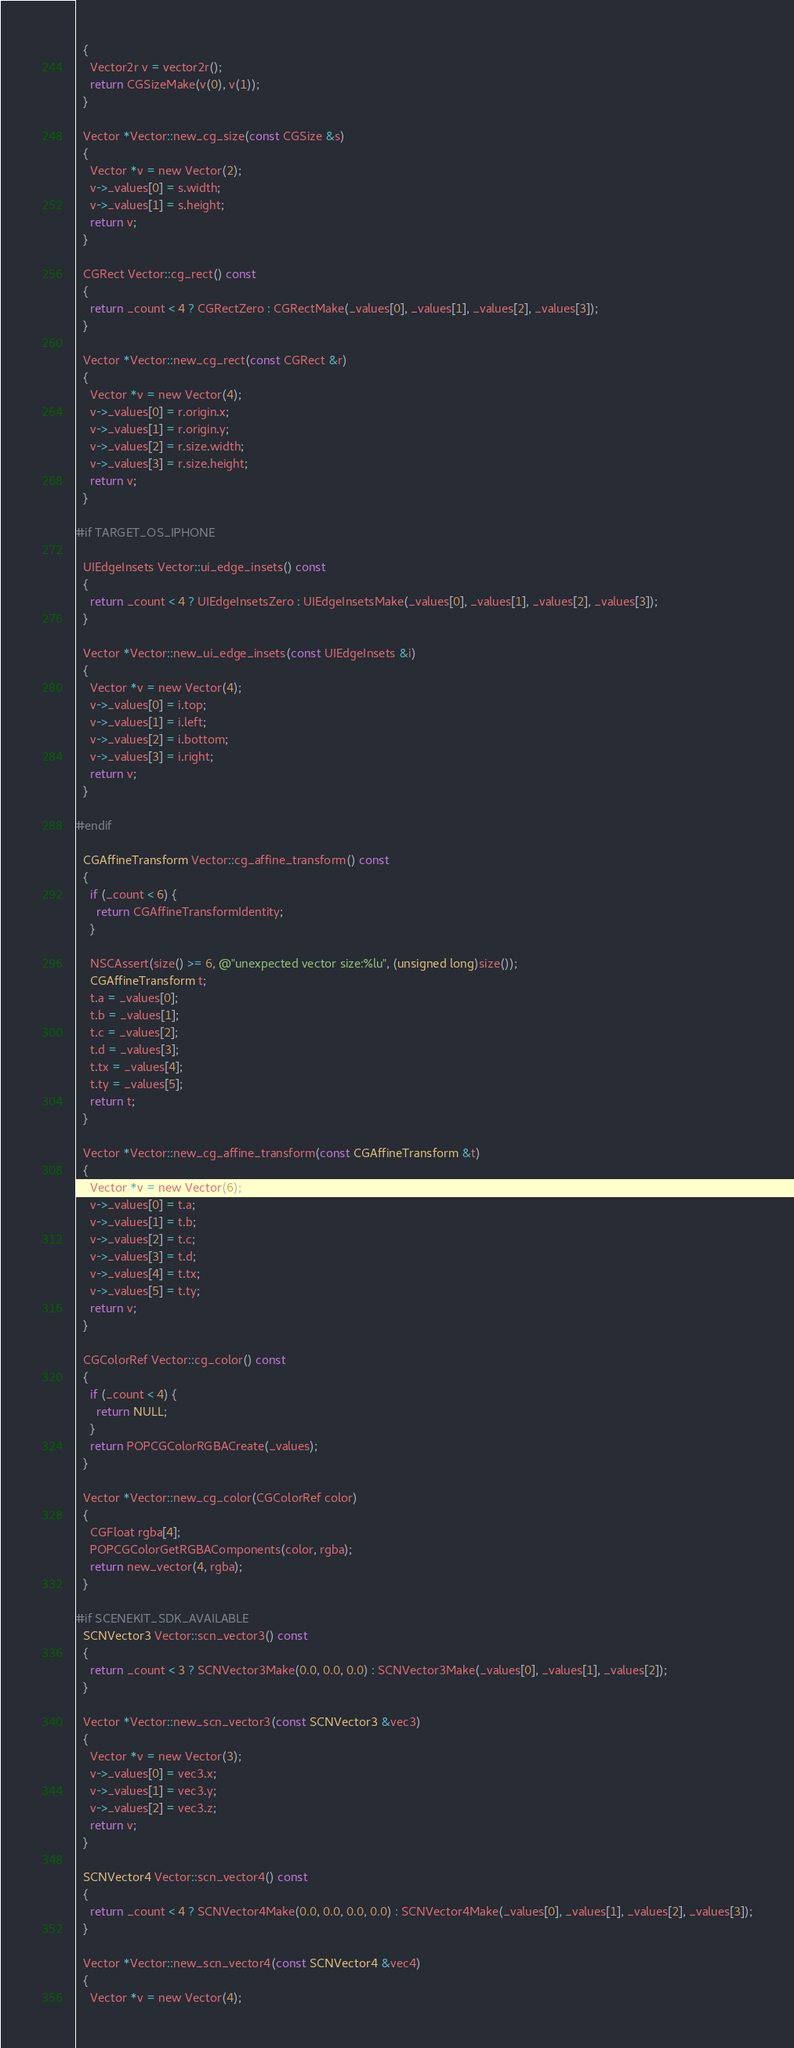<code> <loc_0><loc_0><loc_500><loc_500><_ObjectiveC_>  {
    Vector2r v = vector2r();
    return CGSizeMake(v(0), v(1));
  }

  Vector *Vector::new_cg_size(const CGSize &s)
  {
    Vector *v = new Vector(2);
    v->_values[0] = s.width;
    v->_values[1] = s.height;
    return v;
  }

  CGRect Vector::cg_rect() const
  {
    return _count < 4 ? CGRectZero : CGRectMake(_values[0], _values[1], _values[2], _values[3]);
  }
  
  Vector *Vector::new_cg_rect(const CGRect &r)
  {
    Vector *v = new Vector(4);
    v->_values[0] = r.origin.x;
    v->_values[1] = r.origin.y;
    v->_values[2] = r.size.width;
    v->_values[3] = r.size.height;
    return v;
  }

#if TARGET_OS_IPHONE

  UIEdgeInsets Vector::ui_edge_insets() const
  {
    return _count < 4 ? UIEdgeInsetsZero : UIEdgeInsetsMake(_values[0], _values[1], _values[2], _values[3]);
  }

  Vector *Vector::new_ui_edge_insets(const UIEdgeInsets &i)
  {
    Vector *v = new Vector(4);
    v->_values[0] = i.top;
    v->_values[1] = i.left;
    v->_values[2] = i.bottom;
    v->_values[3] = i.right;
    return v;
  }

#endif

  CGAffineTransform Vector::cg_affine_transform() const
  {
    if (_count < 6) {
      return CGAffineTransformIdentity;
    }

    NSCAssert(size() >= 6, @"unexpected vector size:%lu", (unsigned long)size());
    CGAffineTransform t;
    t.a = _values[0];
    t.b = _values[1];
    t.c = _values[2];
    t.d = _values[3];
    t.tx = _values[4];
    t.ty = _values[5];
    return t;
  }

  Vector *Vector::new_cg_affine_transform(const CGAffineTransform &t)
  {
    Vector *v = new Vector(6);
    v->_values[0] = t.a;
    v->_values[1] = t.b;
    v->_values[2] = t.c;
    v->_values[3] = t.d;
    v->_values[4] = t.tx;
    v->_values[5] = t.ty;
    return v;
  }

  CGColorRef Vector::cg_color() const
  {
    if (_count < 4) {
      return NULL;
    }
    return POPCGColorRGBACreate(_values);
  }

  Vector *Vector::new_cg_color(CGColorRef color)
  {
    CGFloat rgba[4];
    POPCGColorGetRGBAComponents(color, rgba);
    return new_vector(4, rgba);
  }
  
#if SCENEKIT_SDK_AVAILABLE
  SCNVector3 Vector::scn_vector3() const
  {
    return _count < 3 ? SCNVector3Make(0.0, 0.0, 0.0) : SCNVector3Make(_values[0], _values[1], _values[2]);
  }
  
  Vector *Vector::new_scn_vector3(const SCNVector3 &vec3)
  {
    Vector *v = new Vector(3);
    v->_values[0] = vec3.x;
    v->_values[1] = vec3.y;
    v->_values[2] = vec3.z;
    return v;
  }
  
  SCNVector4 Vector::scn_vector4() const
  {
    return _count < 4 ? SCNVector4Make(0.0, 0.0, 0.0, 0.0) : SCNVector4Make(_values[0], _values[1], _values[2], _values[3]);
  }
  
  Vector *Vector::new_scn_vector4(const SCNVector4 &vec4)
  {
    Vector *v = new Vector(4);</code> 